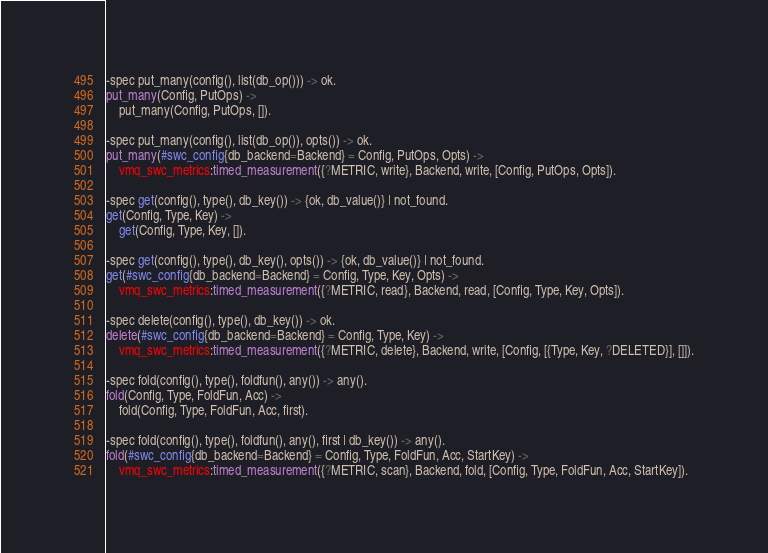Convert code to text. <code><loc_0><loc_0><loc_500><loc_500><_Erlang_>-spec put_many(config(), list(db_op())) -> ok.
put_many(Config, PutOps) ->
    put_many(Config, PutOps, []).

-spec put_many(config(), list(db_op()), opts()) -> ok.
put_many(#swc_config{db_backend=Backend} = Config, PutOps, Opts) ->
    vmq_swc_metrics:timed_measurement({?METRIC, write}, Backend, write, [Config, PutOps, Opts]).

-spec get(config(), type(), db_key()) -> {ok, db_value()} | not_found.
get(Config, Type, Key) ->
    get(Config, Type, Key, []).

-spec get(config(), type(), db_key(), opts()) -> {ok, db_value()} | not_found.
get(#swc_config{db_backend=Backend} = Config, Type, Key, Opts) ->
    vmq_swc_metrics:timed_measurement({?METRIC, read}, Backend, read, [Config, Type, Key, Opts]).

-spec delete(config(), type(), db_key()) -> ok.
delete(#swc_config{db_backend=Backend} = Config, Type, Key) ->
    vmq_swc_metrics:timed_measurement({?METRIC, delete}, Backend, write, [Config, [{Type, Key, ?DELETED}], []]).

-spec fold(config(), type(), foldfun(), any()) -> any().
fold(Config, Type, FoldFun, Acc) ->
    fold(Config, Type, FoldFun, Acc, first).

-spec fold(config(), type(), foldfun(), any(), first | db_key()) -> any().
fold(#swc_config{db_backend=Backend} = Config, Type, FoldFun, Acc, StartKey) ->
    vmq_swc_metrics:timed_measurement({?METRIC, scan}, Backend, fold, [Config, Type, FoldFun, Acc, StartKey]).
</code> 